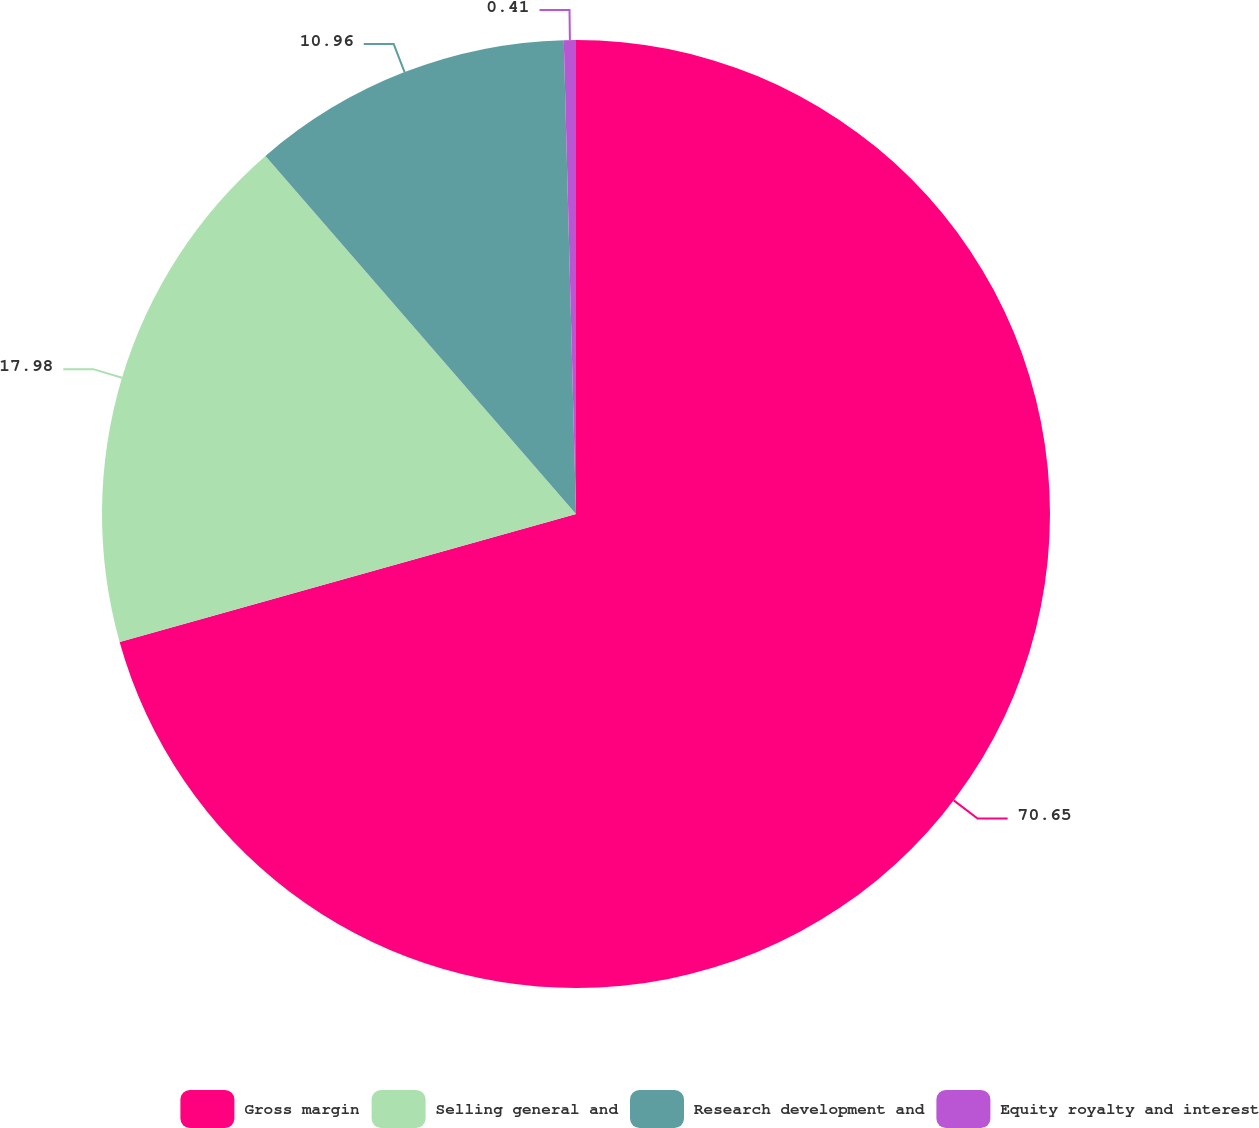Convert chart to OTSL. <chart><loc_0><loc_0><loc_500><loc_500><pie_chart><fcel>Gross margin<fcel>Selling general and<fcel>Research development and<fcel>Equity royalty and interest<nl><fcel>70.65%<fcel>17.98%<fcel>10.96%<fcel>0.41%<nl></chart> 